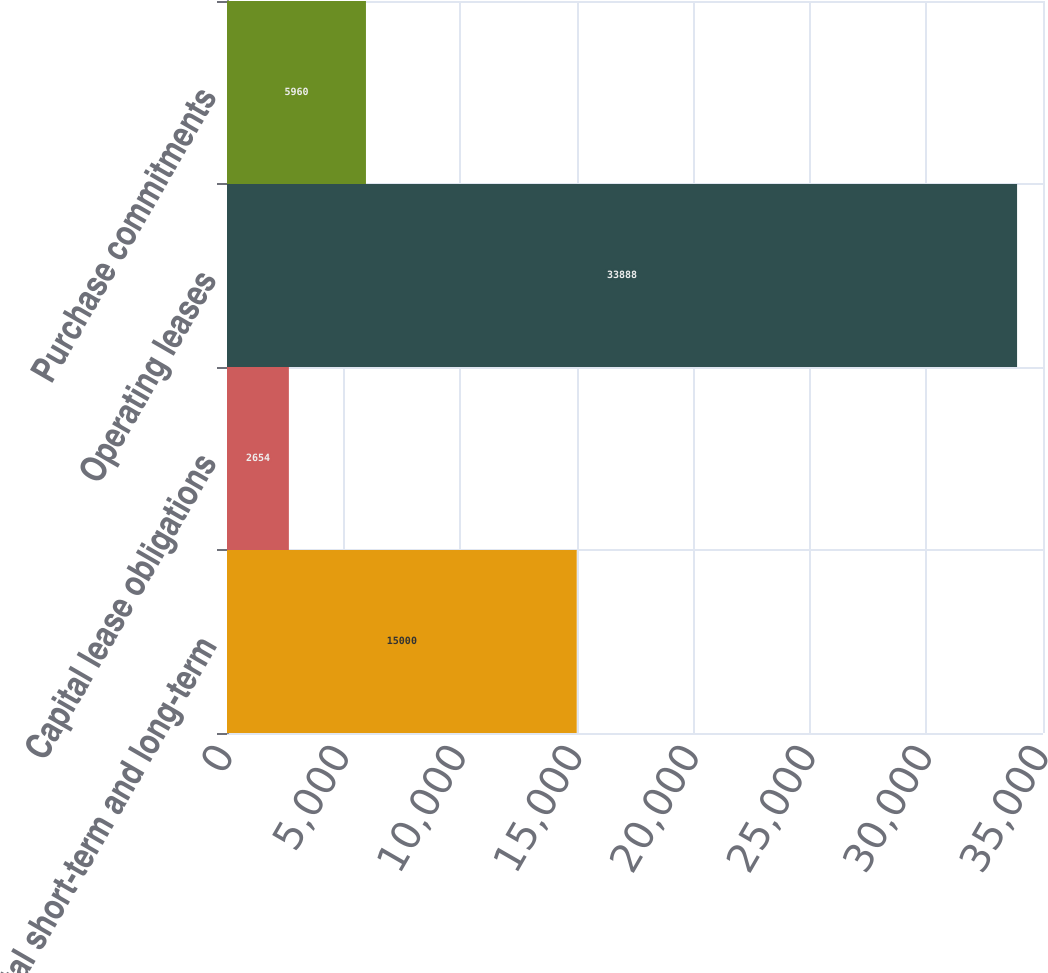Convert chart to OTSL. <chart><loc_0><loc_0><loc_500><loc_500><bar_chart><fcel>Total short-term and long-term<fcel>Capital lease obligations<fcel>Operating leases<fcel>Purchase commitments<nl><fcel>15000<fcel>2654<fcel>33888<fcel>5960<nl></chart> 